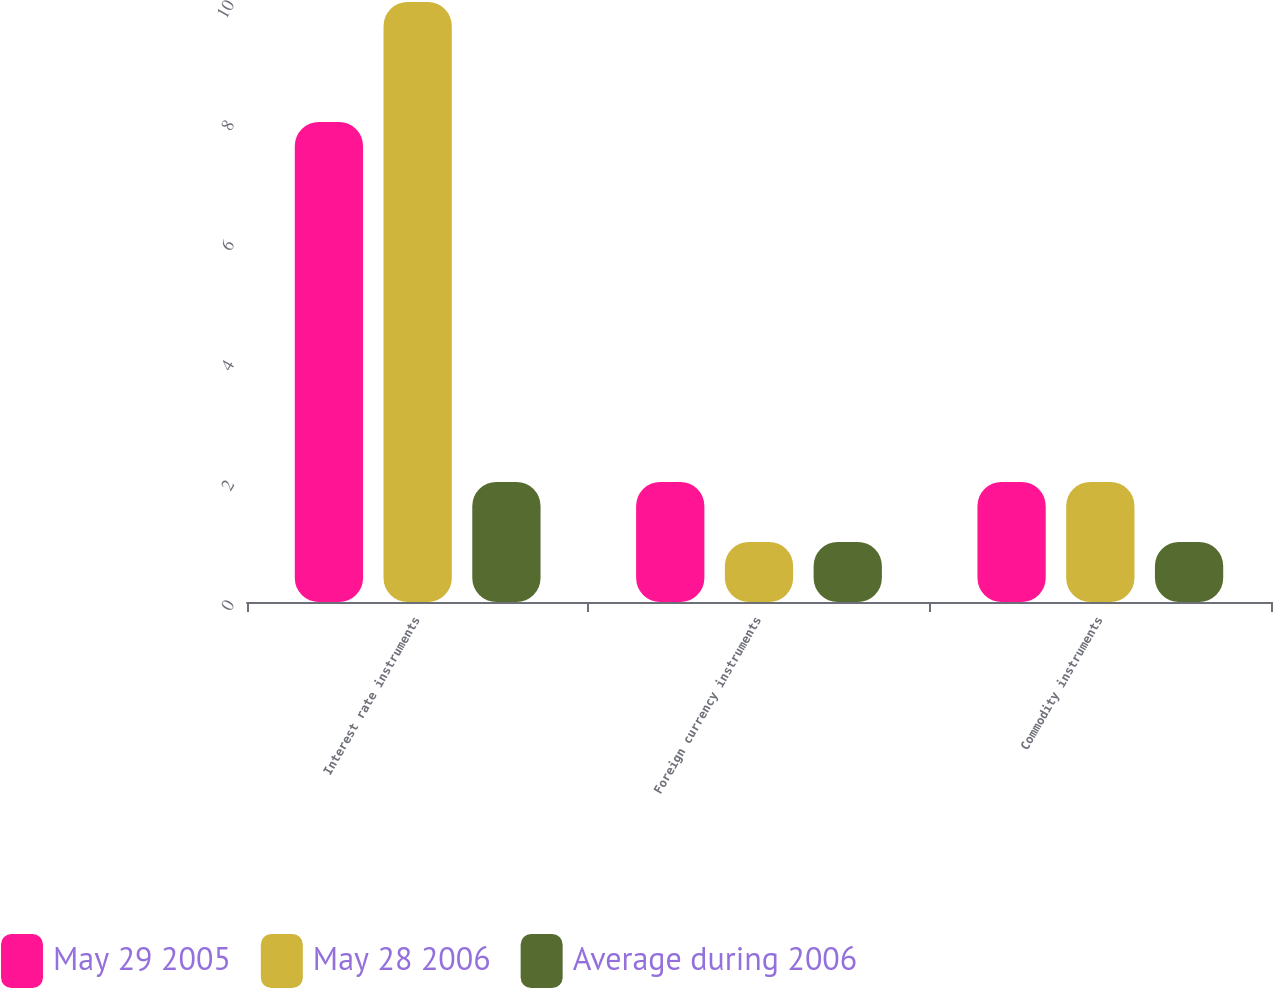<chart> <loc_0><loc_0><loc_500><loc_500><stacked_bar_chart><ecel><fcel>Interest rate instruments<fcel>Foreign currency instruments<fcel>Commodity instruments<nl><fcel>May 29 2005<fcel>8<fcel>2<fcel>2<nl><fcel>May 28 2006<fcel>10<fcel>1<fcel>2<nl><fcel>Average during 2006<fcel>2<fcel>1<fcel>1<nl></chart> 